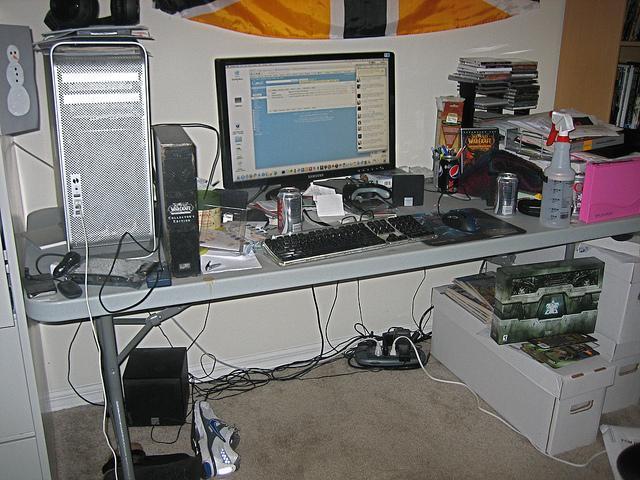How many computers are shown?
Give a very brief answer. 1. 